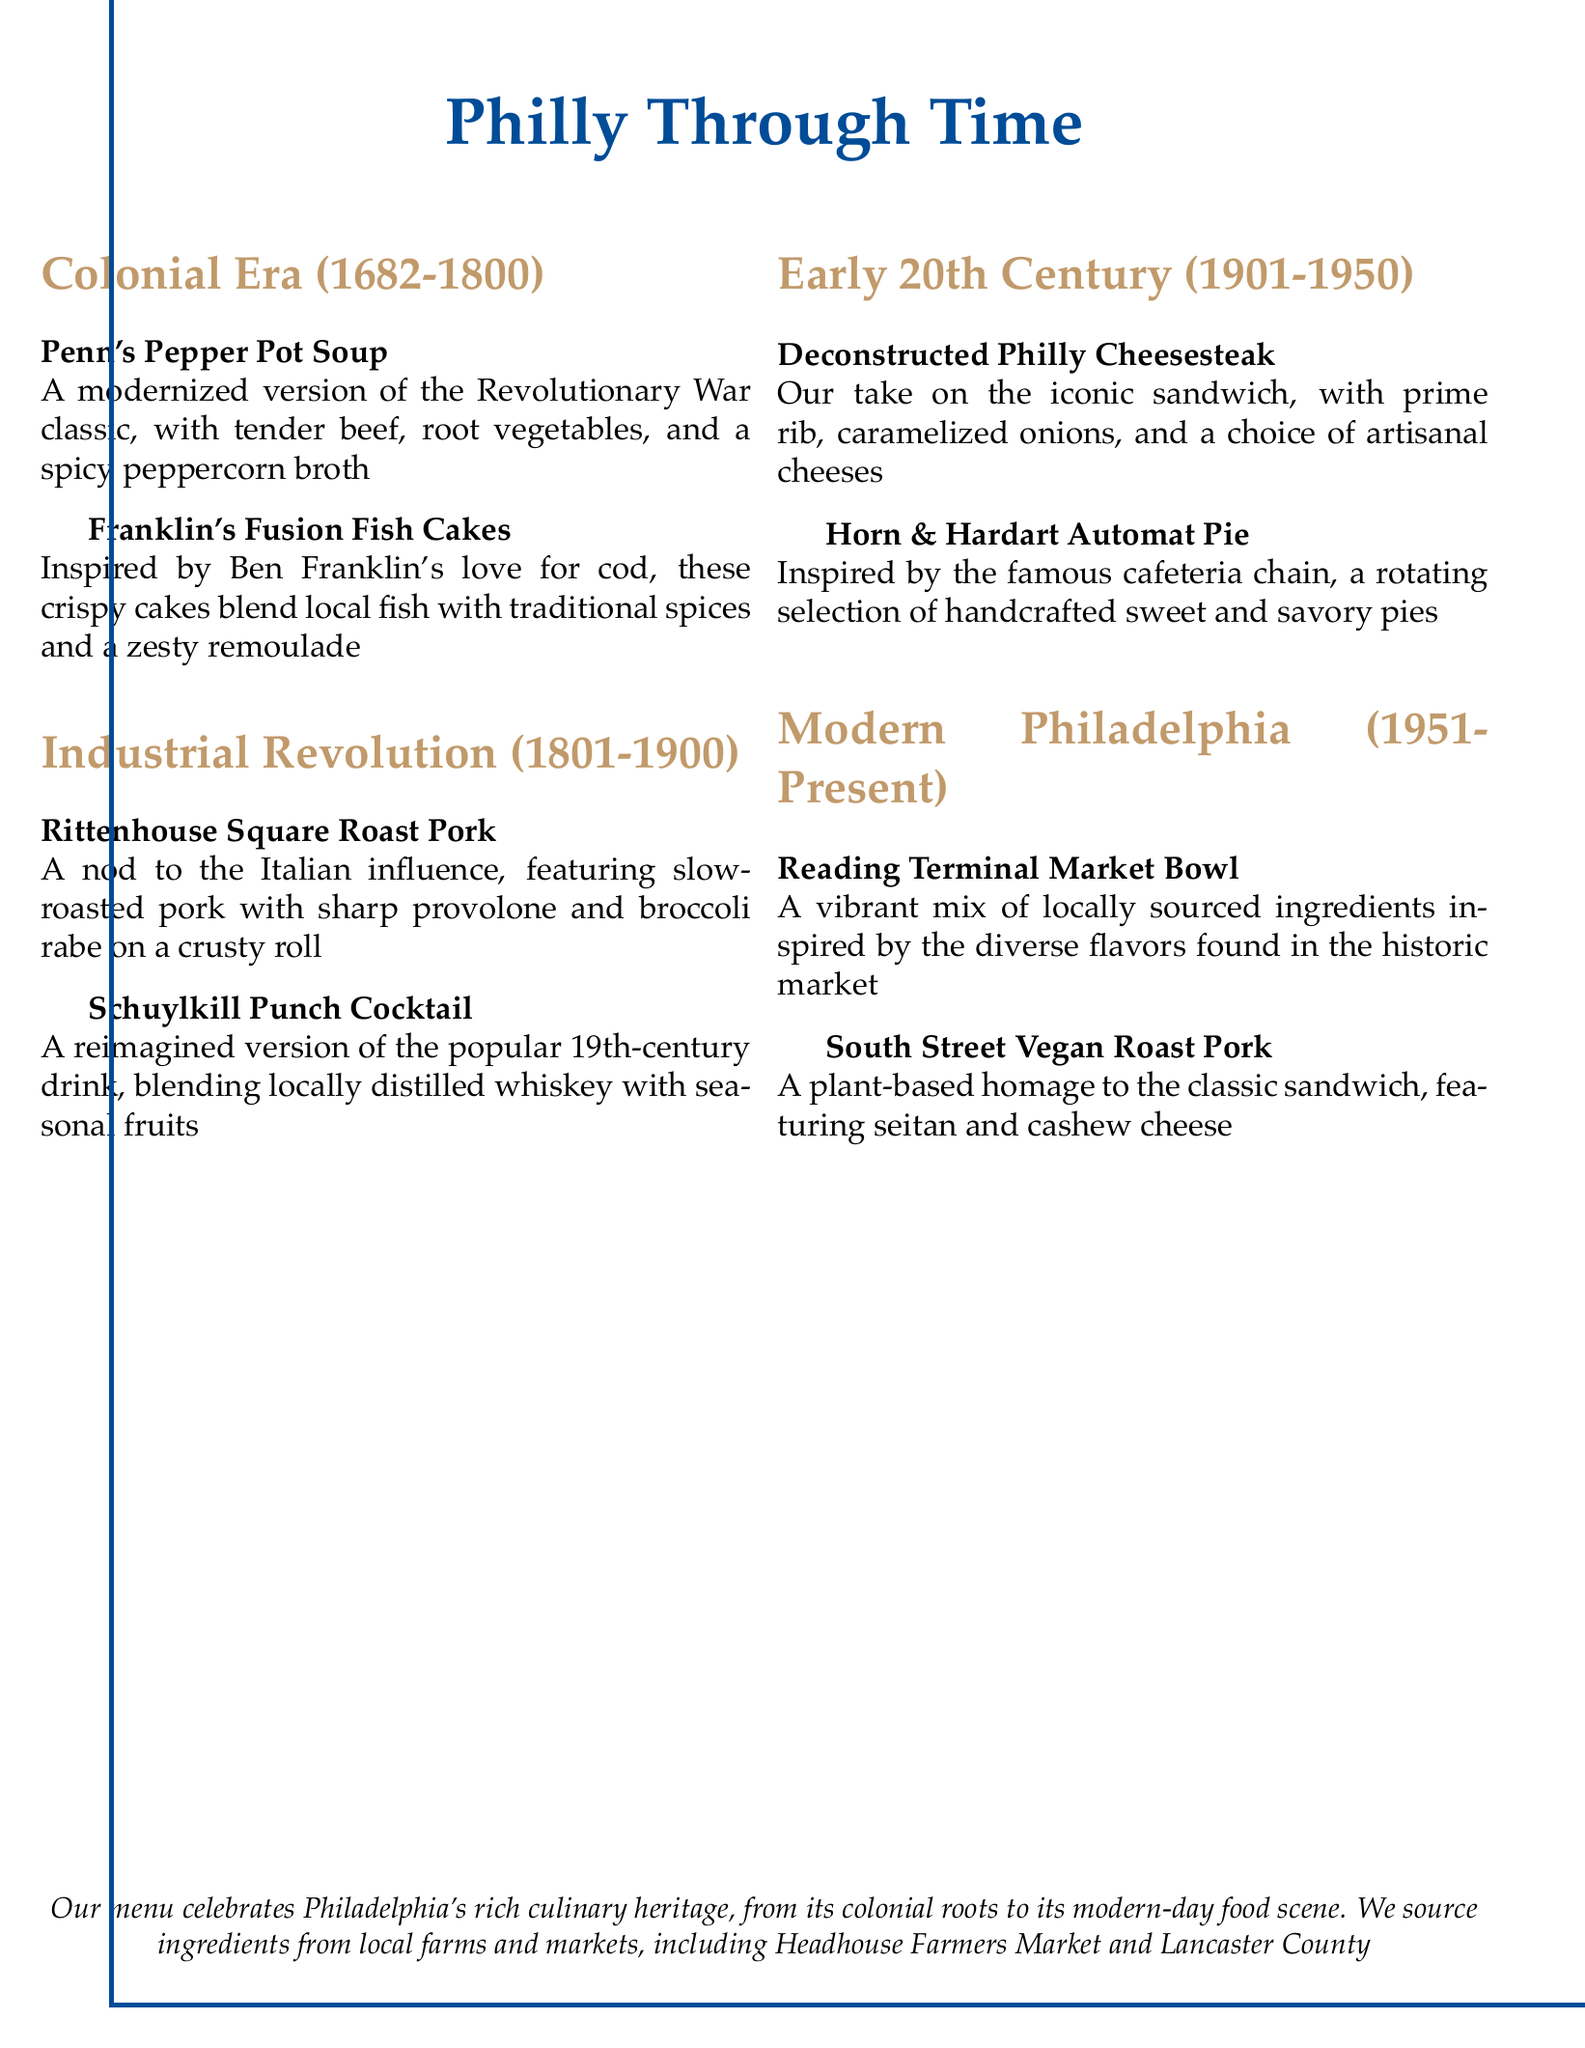What is the name of the soup in the Colonial Era section? The document lists "Penn's Pepper Pot Soup" as the soup in the Colonial Era section.
Answer: Penn's Pepper Pot Soup What type of fish is featured in Franklin's Fusion Fish Cakes? The menu indicates that these cakes blend local fish, but does not specify the exact type of fish; it is inspired by Ben Franklin's love for cod.
Answer: Cod What is the primary meat used in the Rittenhouse Square Roast Pork? The document states that the primary meat for this dish is slow-roasted pork.
Answer: Pork Which cocktail is revived in the Industrial Revolution section? The menu features "Schuylkill Punch Cocktail" as the revived drink in this section.
Answer: Schuylkill Punch Cocktail What ingredient is highlighted in the South Street Vegan Roast Pork? The document mentions seitan as a key ingredient in the plant-based roast pork dish.
Answer: Seitan How many culinary eras are represented in the menu? The menu includes four distinct culinary eras: Colonial Era, Industrial Revolution, Early 20th Century, and Modern Philadelphia, making a total of four.
Answer: Four What type of cheese is mentioned in the Deconstructed Philly Cheesesteak? The menu offers a choice of "artisanal cheeses" for this dish but does not specify particular types of cheese.
Answer: Artisanal cheeses What is the theme of the Reading Terminal Market Bowl? The dish is inspired by the diverse flavors found in the historic market, highlighting "locally sourced ingredients" as its theme.
Answer: Locally sourced ingredients 